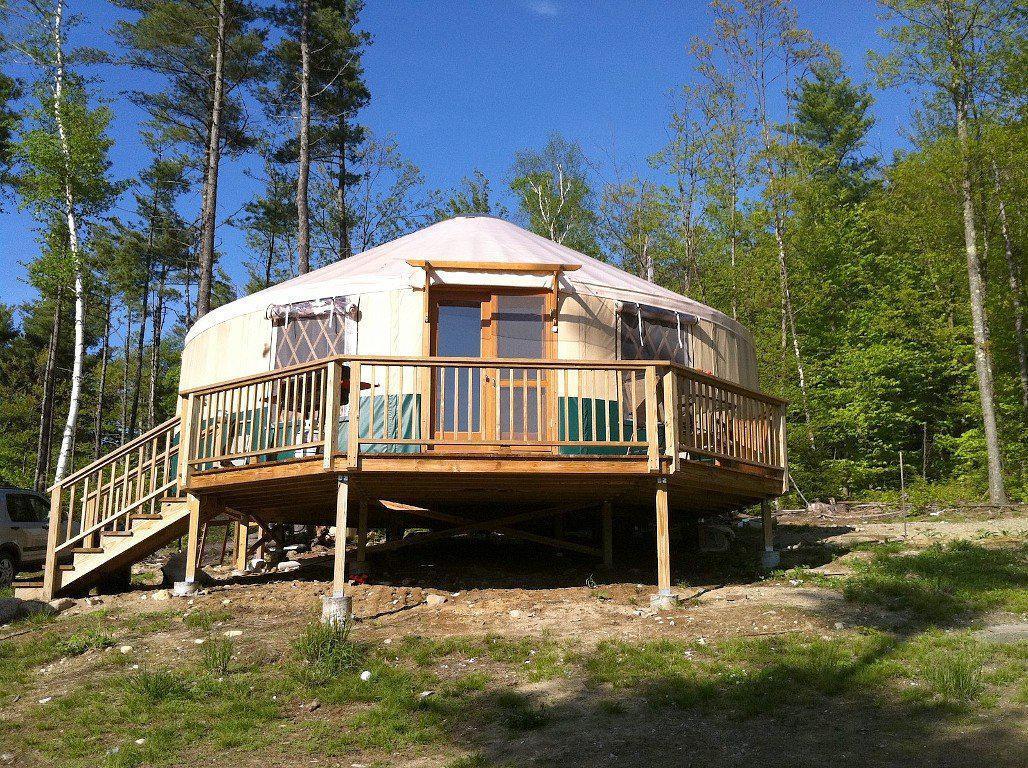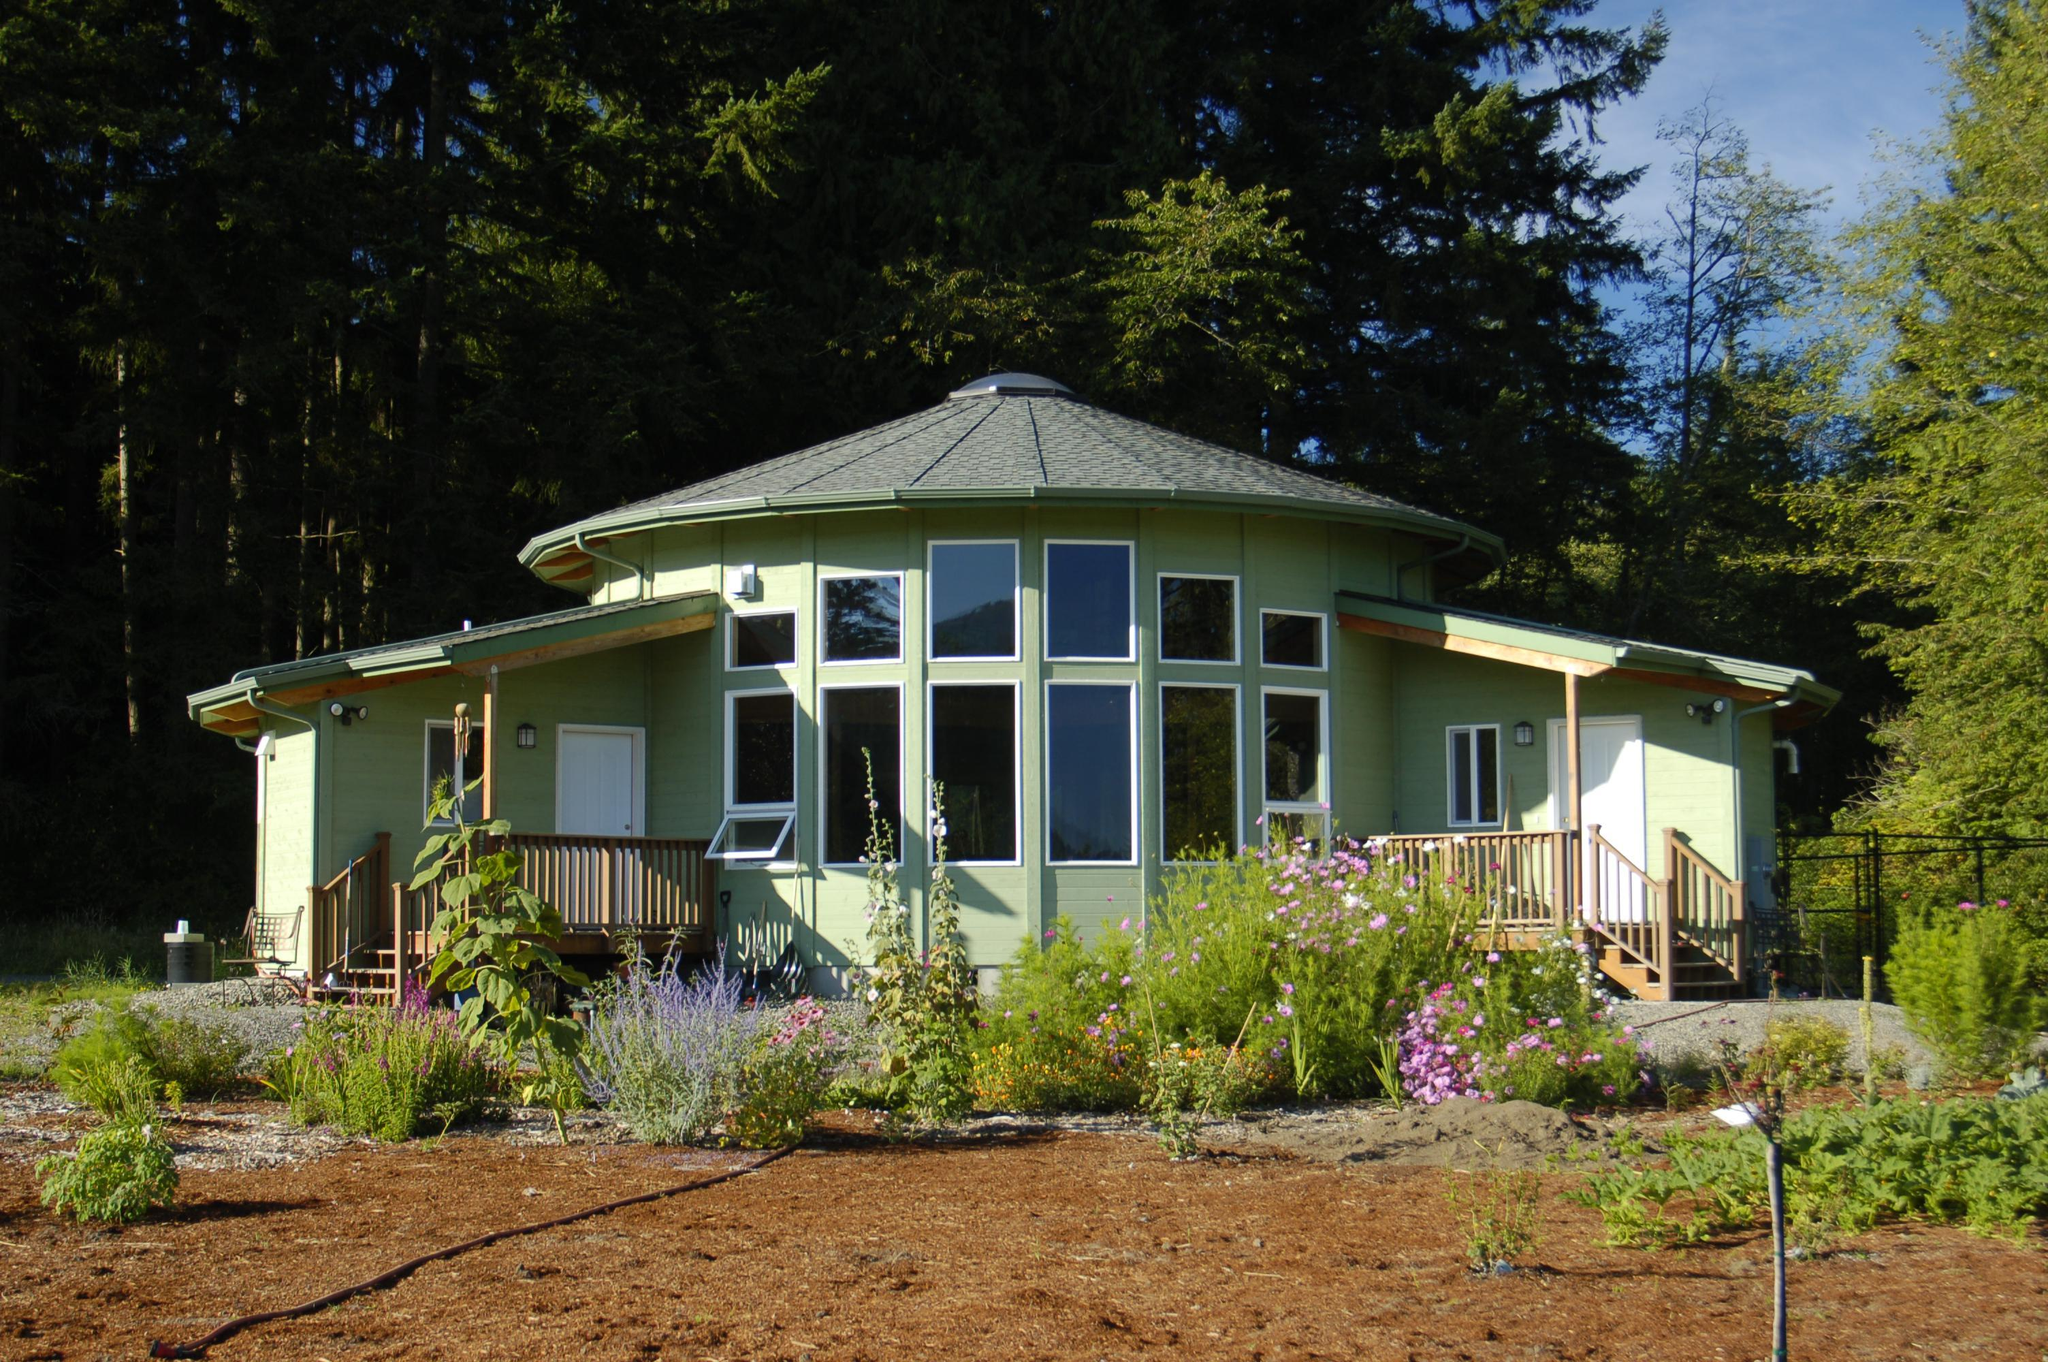The first image is the image on the left, the second image is the image on the right. Evaluate the accuracy of this statement regarding the images: "One image shows a yurt standing on a fresh-water shore, and the other image shows a yurt with decks extending from it and evergreens behind it.". Is it true? Answer yes or no. No. The first image is the image on the left, the second image is the image on the right. Assess this claim about the two images: "A yurt in one image features a white door with nine-pane window and a wooden walkway, but has no visible windows.". Correct or not? Answer yes or no. No. 